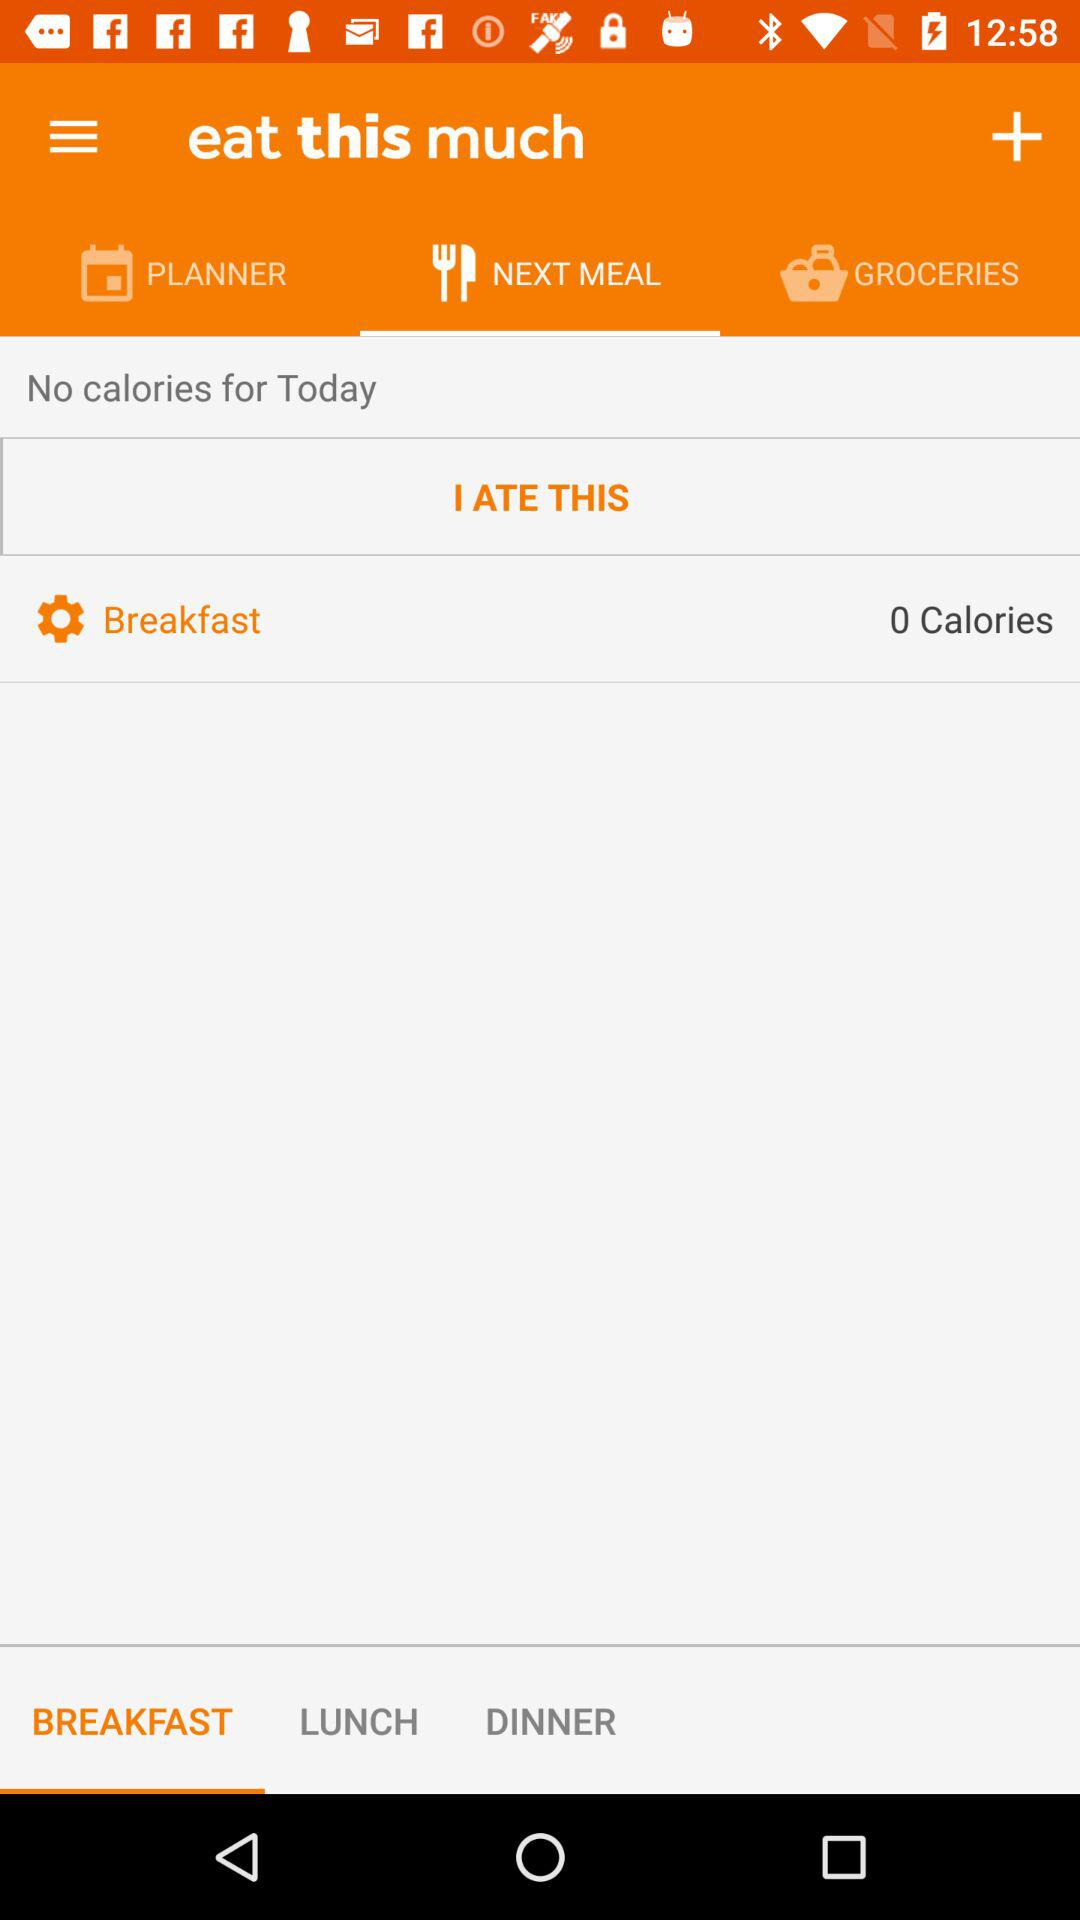How many calories are there in today's meals?
Answer the question using a single word or phrase. 0 